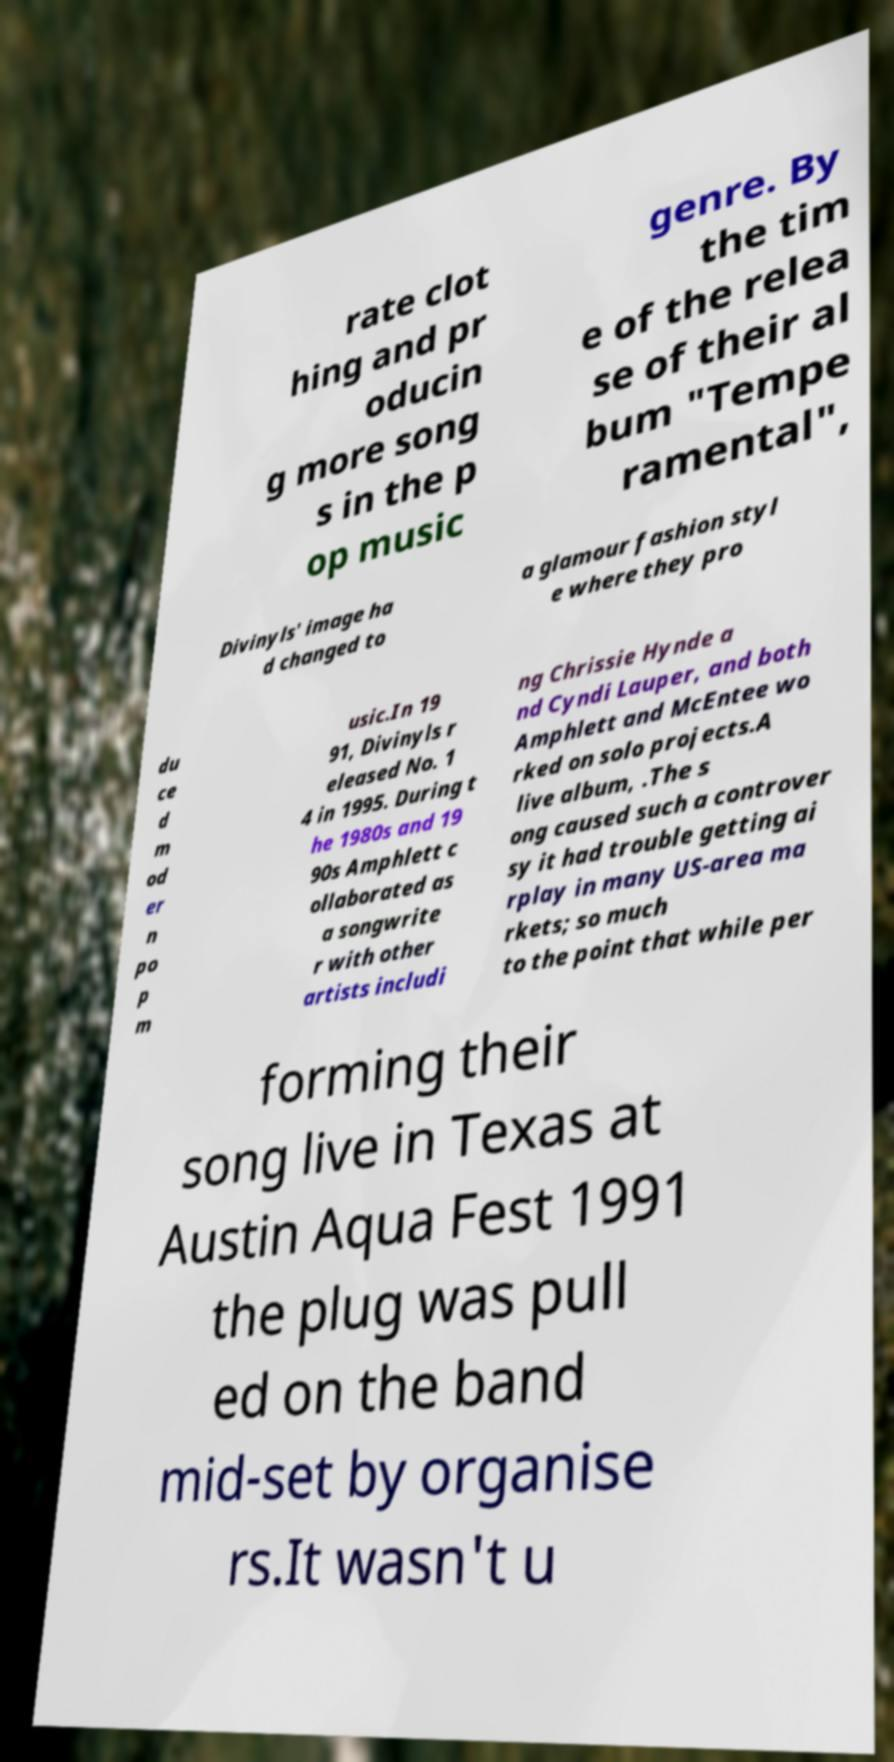Could you extract and type out the text from this image? rate clot hing and pr oducin g more song s in the p op music genre. By the tim e of the relea se of their al bum "Tempe ramental", Divinyls' image ha d changed to a glamour fashion styl e where they pro du ce d m od er n po p m usic.In 19 91, Divinyls r eleased No. 1 4 in 1995. During t he 1980s and 19 90s Amphlett c ollaborated as a songwrite r with other artists includi ng Chrissie Hynde a nd Cyndi Lauper, and both Amphlett and McEntee wo rked on solo projects.A live album, .The s ong caused such a controver sy it had trouble getting ai rplay in many US-area ma rkets; so much to the point that while per forming their song live in Texas at Austin Aqua Fest 1991 the plug was pull ed on the band mid-set by organise rs.It wasn't u 